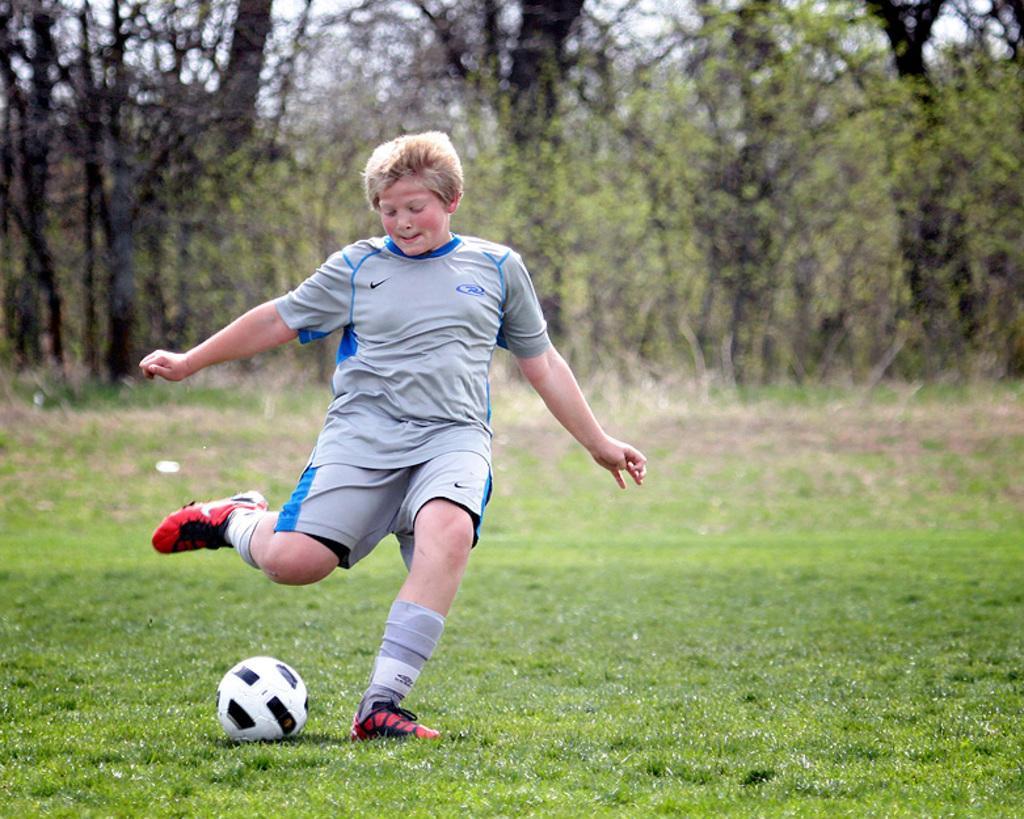In one or two sentences, can you explain what this image depicts? There is a person wearing grey dress is playing football on a greenery ground and there are trees in the background. 